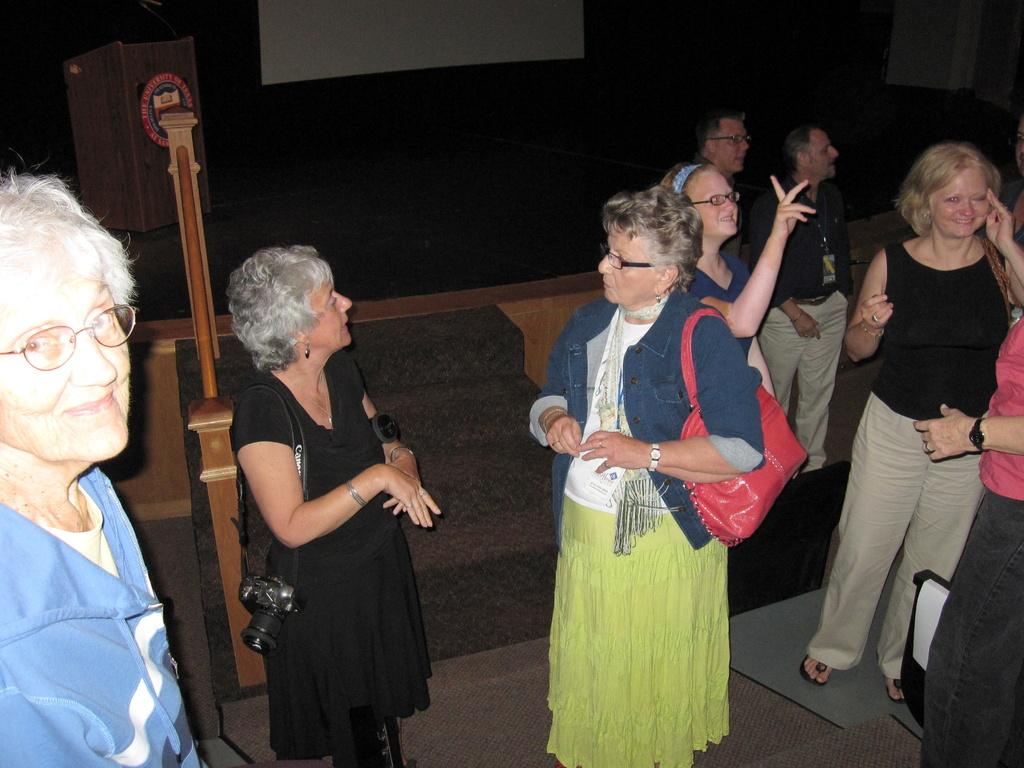What can be seen in the foreground of the picture? There are people standing in the foreground of the picture. What is located in the center of the picture? There is a staircase, a stage, a speaker, and a projector screen in the center of the picture. What type of jelly is being used to drive the calculator in the image? There is no jelly, driving, or calculator present in the image. 